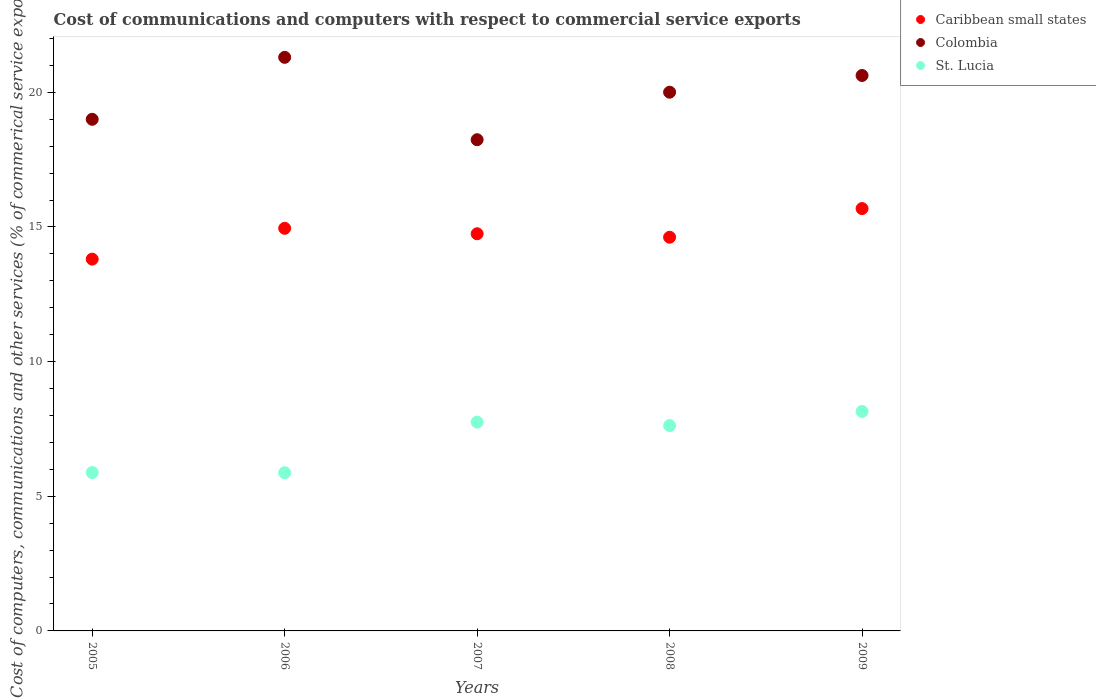How many different coloured dotlines are there?
Your answer should be compact. 3. Is the number of dotlines equal to the number of legend labels?
Provide a short and direct response. Yes. What is the cost of communications and computers in Caribbean small states in 2007?
Offer a very short reply. 14.75. Across all years, what is the maximum cost of communications and computers in St. Lucia?
Make the answer very short. 8.15. Across all years, what is the minimum cost of communications and computers in Caribbean small states?
Ensure brevity in your answer.  13.81. What is the total cost of communications and computers in Colombia in the graph?
Give a very brief answer. 99.17. What is the difference between the cost of communications and computers in Colombia in 2006 and that in 2009?
Give a very brief answer. 0.67. What is the difference between the cost of communications and computers in Colombia in 2006 and the cost of communications and computers in St. Lucia in 2007?
Your answer should be compact. 13.55. What is the average cost of communications and computers in St. Lucia per year?
Keep it short and to the point. 7.06. In the year 2009, what is the difference between the cost of communications and computers in St. Lucia and cost of communications and computers in Colombia?
Make the answer very short. -12.48. What is the ratio of the cost of communications and computers in Colombia in 2007 to that in 2008?
Provide a short and direct response. 0.91. Is the cost of communications and computers in St. Lucia in 2007 less than that in 2009?
Keep it short and to the point. Yes. What is the difference between the highest and the second highest cost of communications and computers in St. Lucia?
Keep it short and to the point. 0.4. What is the difference between the highest and the lowest cost of communications and computers in Caribbean small states?
Ensure brevity in your answer.  1.88. Does the cost of communications and computers in Colombia monotonically increase over the years?
Ensure brevity in your answer.  No. How many years are there in the graph?
Provide a succinct answer. 5. How are the legend labels stacked?
Keep it short and to the point. Vertical. What is the title of the graph?
Provide a succinct answer. Cost of communications and computers with respect to commercial service exports. What is the label or title of the X-axis?
Provide a short and direct response. Years. What is the label or title of the Y-axis?
Offer a very short reply. Cost of computers, communications and other services (% of commerical service exports). What is the Cost of computers, communications and other services (% of commerical service exports) in Caribbean small states in 2005?
Your response must be concise. 13.81. What is the Cost of computers, communications and other services (% of commerical service exports) in Colombia in 2005?
Your answer should be compact. 19. What is the Cost of computers, communications and other services (% of commerical service exports) of St. Lucia in 2005?
Your answer should be very brief. 5.88. What is the Cost of computers, communications and other services (% of commerical service exports) in Caribbean small states in 2006?
Offer a very short reply. 14.95. What is the Cost of computers, communications and other services (% of commerical service exports) of Colombia in 2006?
Your response must be concise. 21.3. What is the Cost of computers, communications and other services (% of commerical service exports) in St. Lucia in 2006?
Offer a terse response. 5.87. What is the Cost of computers, communications and other services (% of commerical service exports) in Caribbean small states in 2007?
Provide a short and direct response. 14.75. What is the Cost of computers, communications and other services (% of commerical service exports) of Colombia in 2007?
Offer a very short reply. 18.24. What is the Cost of computers, communications and other services (% of commerical service exports) of St. Lucia in 2007?
Offer a terse response. 7.75. What is the Cost of computers, communications and other services (% of commerical service exports) in Caribbean small states in 2008?
Give a very brief answer. 14.62. What is the Cost of computers, communications and other services (% of commerical service exports) of Colombia in 2008?
Ensure brevity in your answer.  20. What is the Cost of computers, communications and other services (% of commerical service exports) of St. Lucia in 2008?
Offer a terse response. 7.63. What is the Cost of computers, communications and other services (% of commerical service exports) in Caribbean small states in 2009?
Ensure brevity in your answer.  15.68. What is the Cost of computers, communications and other services (% of commerical service exports) of Colombia in 2009?
Ensure brevity in your answer.  20.63. What is the Cost of computers, communications and other services (% of commerical service exports) of St. Lucia in 2009?
Your answer should be very brief. 8.15. Across all years, what is the maximum Cost of computers, communications and other services (% of commerical service exports) in Caribbean small states?
Provide a succinct answer. 15.68. Across all years, what is the maximum Cost of computers, communications and other services (% of commerical service exports) in Colombia?
Make the answer very short. 21.3. Across all years, what is the maximum Cost of computers, communications and other services (% of commerical service exports) of St. Lucia?
Ensure brevity in your answer.  8.15. Across all years, what is the minimum Cost of computers, communications and other services (% of commerical service exports) of Caribbean small states?
Provide a succinct answer. 13.81. Across all years, what is the minimum Cost of computers, communications and other services (% of commerical service exports) of Colombia?
Your response must be concise. 18.24. Across all years, what is the minimum Cost of computers, communications and other services (% of commerical service exports) of St. Lucia?
Offer a very short reply. 5.87. What is the total Cost of computers, communications and other services (% of commerical service exports) in Caribbean small states in the graph?
Ensure brevity in your answer.  73.81. What is the total Cost of computers, communications and other services (% of commerical service exports) of Colombia in the graph?
Your answer should be very brief. 99.17. What is the total Cost of computers, communications and other services (% of commerical service exports) in St. Lucia in the graph?
Offer a very short reply. 35.28. What is the difference between the Cost of computers, communications and other services (% of commerical service exports) of Caribbean small states in 2005 and that in 2006?
Ensure brevity in your answer.  -1.14. What is the difference between the Cost of computers, communications and other services (% of commerical service exports) in Colombia in 2005 and that in 2006?
Offer a very short reply. -2.3. What is the difference between the Cost of computers, communications and other services (% of commerical service exports) in St. Lucia in 2005 and that in 2006?
Make the answer very short. 0.01. What is the difference between the Cost of computers, communications and other services (% of commerical service exports) in Caribbean small states in 2005 and that in 2007?
Provide a short and direct response. -0.94. What is the difference between the Cost of computers, communications and other services (% of commerical service exports) of Colombia in 2005 and that in 2007?
Provide a short and direct response. 0.76. What is the difference between the Cost of computers, communications and other services (% of commerical service exports) in St. Lucia in 2005 and that in 2007?
Offer a terse response. -1.87. What is the difference between the Cost of computers, communications and other services (% of commerical service exports) in Caribbean small states in 2005 and that in 2008?
Your answer should be compact. -0.81. What is the difference between the Cost of computers, communications and other services (% of commerical service exports) of Colombia in 2005 and that in 2008?
Provide a short and direct response. -1.01. What is the difference between the Cost of computers, communications and other services (% of commerical service exports) of St. Lucia in 2005 and that in 2008?
Your response must be concise. -1.74. What is the difference between the Cost of computers, communications and other services (% of commerical service exports) of Caribbean small states in 2005 and that in 2009?
Provide a succinct answer. -1.88. What is the difference between the Cost of computers, communications and other services (% of commerical service exports) in Colombia in 2005 and that in 2009?
Keep it short and to the point. -1.63. What is the difference between the Cost of computers, communications and other services (% of commerical service exports) of St. Lucia in 2005 and that in 2009?
Ensure brevity in your answer.  -2.27. What is the difference between the Cost of computers, communications and other services (% of commerical service exports) of Caribbean small states in 2006 and that in 2007?
Make the answer very short. 0.2. What is the difference between the Cost of computers, communications and other services (% of commerical service exports) in Colombia in 2006 and that in 2007?
Offer a very short reply. 3.06. What is the difference between the Cost of computers, communications and other services (% of commerical service exports) of St. Lucia in 2006 and that in 2007?
Offer a terse response. -1.88. What is the difference between the Cost of computers, communications and other services (% of commerical service exports) in Caribbean small states in 2006 and that in 2008?
Your answer should be very brief. 0.33. What is the difference between the Cost of computers, communications and other services (% of commerical service exports) of Colombia in 2006 and that in 2008?
Offer a very short reply. 1.29. What is the difference between the Cost of computers, communications and other services (% of commerical service exports) of St. Lucia in 2006 and that in 2008?
Provide a succinct answer. -1.75. What is the difference between the Cost of computers, communications and other services (% of commerical service exports) of Caribbean small states in 2006 and that in 2009?
Keep it short and to the point. -0.73. What is the difference between the Cost of computers, communications and other services (% of commerical service exports) in Colombia in 2006 and that in 2009?
Provide a succinct answer. 0.67. What is the difference between the Cost of computers, communications and other services (% of commerical service exports) in St. Lucia in 2006 and that in 2009?
Give a very brief answer. -2.27. What is the difference between the Cost of computers, communications and other services (% of commerical service exports) in Caribbean small states in 2007 and that in 2008?
Ensure brevity in your answer.  0.13. What is the difference between the Cost of computers, communications and other services (% of commerical service exports) of Colombia in 2007 and that in 2008?
Offer a very short reply. -1.76. What is the difference between the Cost of computers, communications and other services (% of commerical service exports) in St. Lucia in 2007 and that in 2008?
Provide a succinct answer. 0.13. What is the difference between the Cost of computers, communications and other services (% of commerical service exports) in Caribbean small states in 2007 and that in 2009?
Provide a short and direct response. -0.94. What is the difference between the Cost of computers, communications and other services (% of commerical service exports) in Colombia in 2007 and that in 2009?
Keep it short and to the point. -2.38. What is the difference between the Cost of computers, communications and other services (% of commerical service exports) in St. Lucia in 2007 and that in 2009?
Your response must be concise. -0.4. What is the difference between the Cost of computers, communications and other services (% of commerical service exports) in Caribbean small states in 2008 and that in 2009?
Offer a terse response. -1.06. What is the difference between the Cost of computers, communications and other services (% of commerical service exports) in Colombia in 2008 and that in 2009?
Keep it short and to the point. -0.62. What is the difference between the Cost of computers, communications and other services (% of commerical service exports) in St. Lucia in 2008 and that in 2009?
Your answer should be compact. -0.52. What is the difference between the Cost of computers, communications and other services (% of commerical service exports) in Caribbean small states in 2005 and the Cost of computers, communications and other services (% of commerical service exports) in Colombia in 2006?
Your answer should be very brief. -7.49. What is the difference between the Cost of computers, communications and other services (% of commerical service exports) of Caribbean small states in 2005 and the Cost of computers, communications and other services (% of commerical service exports) of St. Lucia in 2006?
Provide a succinct answer. 7.93. What is the difference between the Cost of computers, communications and other services (% of commerical service exports) of Colombia in 2005 and the Cost of computers, communications and other services (% of commerical service exports) of St. Lucia in 2006?
Your answer should be very brief. 13.12. What is the difference between the Cost of computers, communications and other services (% of commerical service exports) of Caribbean small states in 2005 and the Cost of computers, communications and other services (% of commerical service exports) of Colombia in 2007?
Keep it short and to the point. -4.43. What is the difference between the Cost of computers, communications and other services (% of commerical service exports) in Caribbean small states in 2005 and the Cost of computers, communications and other services (% of commerical service exports) in St. Lucia in 2007?
Keep it short and to the point. 6.05. What is the difference between the Cost of computers, communications and other services (% of commerical service exports) in Colombia in 2005 and the Cost of computers, communications and other services (% of commerical service exports) in St. Lucia in 2007?
Your answer should be compact. 11.25. What is the difference between the Cost of computers, communications and other services (% of commerical service exports) of Caribbean small states in 2005 and the Cost of computers, communications and other services (% of commerical service exports) of Colombia in 2008?
Keep it short and to the point. -6.2. What is the difference between the Cost of computers, communications and other services (% of commerical service exports) of Caribbean small states in 2005 and the Cost of computers, communications and other services (% of commerical service exports) of St. Lucia in 2008?
Your answer should be compact. 6.18. What is the difference between the Cost of computers, communications and other services (% of commerical service exports) in Colombia in 2005 and the Cost of computers, communications and other services (% of commerical service exports) in St. Lucia in 2008?
Your response must be concise. 11.37. What is the difference between the Cost of computers, communications and other services (% of commerical service exports) in Caribbean small states in 2005 and the Cost of computers, communications and other services (% of commerical service exports) in Colombia in 2009?
Give a very brief answer. -6.82. What is the difference between the Cost of computers, communications and other services (% of commerical service exports) in Caribbean small states in 2005 and the Cost of computers, communications and other services (% of commerical service exports) in St. Lucia in 2009?
Provide a short and direct response. 5.66. What is the difference between the Cost of computers, communications and other services (% of commerical service exports) in Colombia in 2005 and the Cost of computers, communications and other services (% of commerical service exports) in St. Lucia in 2009?
Ensure brevity in your answer.  10.85. What is the difference between the Cost of computers, communications and other services (% of commerical service exports) of Caribbean small states in 2006 and the Cost of computers, communications and other services (% of commerical service exports) of Colombia in 2007?
Offer a very short reply. -3.29. What is the difference between the Cost of computers, communications and other services (% of commerical service exports) in Caribbean small states in 2006 and the Cost of computers, communications and other services (% of commerical service exports) in St. Lucia in 2007?
Your answer should be compact. 7.2. What is the difference between the Cost of computers, communications and other services (% of commerical service exports) of Colombia in 2006 and the Cost of computers, communications and other services (% of commerical service exports) of St. Lucia in 2007?
Your response must be concise. 13.55. What is the difference between the Cost of computers, communications and other services (% of commerical service exports) of Caribbean small states in 2006 and the Cost of computers, communications and other services (% of commerical service exports) of Colombia in 2008?
Make the answer very short. -5.05. What is the difference between the Cost of computers, communications and other services (% of commerical service exports) in Caribbean small states in 2006 and the Cost of computers, communications and other services (% of commerical service exports) in St. Lucia in 2008?
Your response must be concise. 7.33. What is the difference between the Cost of computers, communications and other services (% of commerical service exports) in Colombia in 2006 and the Cost of computers, communications and other services (% of commerical service exports) in St. Lucia in 2008?
Offer a terse response. 13.67. What is the difference between the Cost of computers, communications and other services (% of commerical service exports) in Caribbean small states in 2006 and the Cost of computers, communications and other services (% of commerical service exports) in Colombia in 2009?
Offer a very short reply. -5.67. What is the difference between the Cost of computers, communications and other services (% of commerical service exports) in Caribbean small states in 2006 and the Cost of computers, communications and other services (% of commerical service exports) in St. Lucia in 2009?
Provide a succinct answer. 6.8. What is the difference between the Cost of computers, communications and other services (% of commerical service exports) in Colombia in 2006 and the Cost of computers, communications and other services (% of commerical service exports) in St. Lucia in 2009?
Provide a succinct answer. 13.15. What is the difference between the Cost of computers, communications and other services (% of commerical service exports) in Caribbean small states in 2007 and the Cost of computers, communications and other services (% of commerical service exports) in Colombia in 2008?
Offer a very short reply. -5.26. What is the difference between the Cost of computers, communications and other services (% of commerical service exports) of Caribbean small states in 2007 and the Cost of computers, communications and other services (% of commerical service exports) of St. Lucia in 2008?
Keep it short and to the point. 7.12. What is the difference between the Cost of computers, communications and other services (% of commerical service exports) in Colombia in 2007 and the Cost of computers, communications and other services (% of commerical service exports) in St. Lucia in 2008?
Ensure brevity in your answer.  10.62. What is the difference between the Cost of computers, communications and other services (% of commerical service exports) in Caribbean small states in 2007 and the Cost of computers, communications and other services (% of commerical service exports) in Colombia in 2009?
Your answer should be compact. -5.88. What is the difference between the Cost of computers, communications and other services (% of commerical service exports) of Caribbean small states in 2007 and the Cost of computers, communications and other services (% of commerical service exports) of St. Lucia in 2009?
Offer a terse response. 6.6. What is the difference between the Cost of computers, communications and other services (% of commerical service exports) in Colombia in 2007 and the Cost of computers, communications and other services (% of commerical service exports) in St. Lucia in 2009?
Your answer should be very brief. 10.09. What is the difference between the Cost of computers, communications and other services (% of commerical service exports) in Caribbean small states in 2008 and the Cost of computers, communications and other services (% of commerical service exports) in Colombia in 2009?
Your response must be concise. -6.01. What is the difference between the Cost of computers, communications and other services (% of commerical service exports) in Caribbean small states in 2008 and the Cost of computers, communications and other services (% of commerical service exports) in St. Lucia in 2009?
Make the answer very short. 6.47. What is the difference between the Cost of computers, communications and other services (% of commerical service exports) in Colombia in 2008 and the Cost of computers, communications and other services (% of commerical service exports) in St. Lucia in 2009?
Your response must be concise. 11.86. What is the average Cost of computers, communications and other services (% of commerical service exports) of Caribbean small states per year?
Make the answer very short. 14.76. What is the average Cost of computers, communications and other services (% of commerical service exports) in Colombia per year?
Your answer should be very brief. 19.83. What is the average Cost of computers, communications and other services (% of commerical service exports) in St. Lucia per year?
Keep it short and to the point. 7.06. In the year 2005, what is the difference between the Cost of computers, communications and other services (% of commerical service exports) of Caribbean small states and Cost of computers, communications and other services (% of commerical service exports) of Colombia?
Provide a short and direct response. -5.19. In the year 2005, what is the difference between the Cost of computers, communications and other services (% of commerical service exports) of Caribbean small states and Cost of computers, communications and other services (% of commerical service exports) of St. Lucia?
Ensure brevity in your answer.  7.93. In the year 2005, what is the difference between the Cost of computers, communications and other services (% of commerical service exports) of Colombia and Cost of computers, communications and other services (% of commerical service exports) of St. Lucia?
Keep it short and to the point. 13.12. In the year 2006, what is the difference between the Cost of computers, communications and other services (% of commerical service exports) of Caribbean small states and Cost of computers, communications and other services (% of commerical service exports) of Colombia?
Offer a terse response. -6.35. In the year 2006, what is the difference between the Cost of computers, communications and other services (% of commerical service exports) of Caribbean small states and Cost of computers, communications and other services (% of commerical service exports) of St. Lucia?
Make the answer very short. 9.08. In the year 2006, what is the difference between the Cost of computers, communications and other services (% of commerical service exports) of Colombia and Cost of computers, communications and other services (% of commerical service exports) of St. Lucia?
Ensure brevity in your answer.  15.42. In the year 2007, what is the difference between the Cost of computers, communications and other services (% of commerical service exports) in Caribbean small states and Cost of computers, communications and other services (% of commerical service exports) in Colombia?
Your answer should be very brief. -3.49. In the year 2007, what is the difference between the Cost of computers, communications and other services (% of commerical service exports) in Caribbean small states and Cost of computers, communications and other services (% of commerical service exports) in St. Lucia?
Provide a short and direct response. 6.99. In the year 2007, what is the difference between the Cost of computers, communications and other services (% of commerical service exports) in Colombia and Cost of computers, communications and other services (% of commerical service exports) in St. Lucia?
Your answer should be compact. 10.49. In the year 2008, what is the difference between the Cost of computers, communications and other services (% of commerical service exports) in Caribbean small states and Cost of computers, communications and other services (% of commerical service exports) in Colombia?
Your response must be concise. -5.38. In the year 2008, what is the difference between the Cost of computers, communications and other services (% of commerical service exports) in Caribbean small states and Cost of computers, communications and other services (% of commerical service exports) in St. Lucia?
Your answer should be compact. 6.99. In the year 2008, what is the difference between the Cost of computers, communications and other services (% of commerical service exports) in Colombia and Cost of computers, communications and other services (% of commerical service exports) in St. Lucia?
Make the answer very short. 12.38. In the year 2009, what is the difference between the Cost of computers, communications and other services (% of commerical service exports) in Caribbean small states and Cost of computers, communications and other services (% of commerical service exports) in Colombia?
Ensure brevity in your answer.  -4.94. In the year 2009, what is the difference between the Cost of computers, communications and other services (% of commerical service exports) in Caribbean small states and Cost of computers, communications and other services (% of commerical service exports) in St. Lucia?
Offer a very short reply. 7.53. In the year 2009, what is the difference between the Cost of computers, communications and other services (% of commerical service exports) in Colombia and Cost of computers, communications and other services (% of commerical service exports) in St. Lucia?
Your answer should be compact. 12.48. What is the ratio of the Cost of computers, communications and other services (% of commerical service exports) of Caribbean small states in 2005 to that in 2006?
Ensure brevity in your answer.  0.92. What is the ratio of the Cost of computers, communications and other services (% of commerical service exports) of Colombia in 2005 to that in 2006?
Ensure brevity in your answer.  0.89. What is the ratio of the Cost of computers, communications and other services (% of commerical service exports) in St. Lucia in 2005 to that in 2006?
Offer a terse response. 1. What is the ratio of the Cost of computers, communications and other services (% of commerical service exports) of Caribbean small states in 2005 to that in 2007?
Keep it short and to the point. 0.94. What is the ratio of the Cost of computers, communications and other services (% of commerical service exports) of Colombia in 2005 to that in 2007?
Your response must be concise. 1.04. What is the ratio of the Cost of computers, communications and other services (% of commerical service exports) of St. Lucia in 2005 to that in 2007?
Ensure brevity in your answer.  0.76. What is the ratio of the Cost of computers, communications and other services (% of commerical service exports) in Caribbean small states in 2005 to that in 2008?
Your answer should be very brief. 0.94. What is the ratio of the Cost of computers, communications and other services (% of commerical service exports) of Colombia in 2005 to that in 2008?
Give a very brief answer. 0.95. What is the ratio of the Cost of computers, communications and other services (% of commerical service exports) in St. Lucia in 2005 to that in 2008?
Your answer should be very brief. 0.77. What is the ratio of the Cost of computers, communications and other services (% of commerical service exports) in Caribbean small states in 2005 to that in 2009?
Your answer should be compact. 0.88. What is the ratio of the Cost of computers, communications and other services (% of commerical service exports) of Colombia in 2005 to that in 2009?
Provide a short and direct response. 0.92. What is the ratio of the Cost of computers, communications and other services (% of commerical service exports) in St. Lucia in 2005 to that in 2009?
Provide a succinct answer. 0.72. What is the ratio of the Cost of computers, communications and other services (% of commerical service exports) of Caribbean small states in 2006 to that in 2007?
Your answer should be very brief. 1.01. What is the ratio of the Cost of computers, communications and other services (% of commerical service exports) in Colombia in 2006 to that in 2007?
Ensure brevity in your answer.  1.17. What is the ratio of the Cost of computers, communications and other services (% of commerical service exports) of St. Lucia in 2006 to that in 2007?
Your answer should be compact. 0.76. What is the ratio of the Cost of computers, communications and other services (% of commerical service exports) in Caribbean small states in 2006 to that in 2008?
Provide a succinct answer. 1.02. What is the ratio of the Cost of computers, communications and other services (% of commerical service exports) of Colombia in 2006 to that in 2008?
Provide a short and direct response. 1.06. What is the ratio of the Cost of computers, communications and other services (% of commerical service exports) of St. Lucia in 2006 to that in 2008?
Provide a short and direct response. 0.77. What is the ratio of the Cost of computers, communications and other services (% of commerical service exports) in Caribbean small states in 2006 to that in 2009?
Keep it short and to the point. 0.95. What is the ratio of the Cost of computers, communications and other services (% of commerical service exports) in Colombia in 2006 to that in 2009?
Ensure brevity in your answer.  1.03. What is the ratio of the Cost of computers, communications and other services (% of commerical service exports) of St. Lucia in 2006 to that in 2009?
Offer a very short reply. 0.72. What is the ratio of the Cost of computers, communications and other services (% of commerical service exports) of Caribbean small states in 2007 to that in 2008?
Provide a succinct answer. 1.01. What is the ratio of the Cost of computers, communications and other services (% of commerical service exports) of Colombia in 2007 to that in 2008?
Give a very brief answer. 0.91. What is the ratio of the Cost of computers, communications and other services (% of commerical service exports) of St. Lucia in 2007 to that in 2008?
Your response must be concise. 1.02. What is the ratio of the Cost of computers, communications and other services (% of commerical service exports) in Caribbean small states in 2007 to that in 2009?
Your answer should be compact. 0.94. What is the ratio of the Cost of computers, communications and other services (% of commerical service exports) in Colombia in 2007 to that in 2009?
Make the answer very short. 0.88. What is the ratio of the Cost of computers, communications and other services (% of commerical service exports) of St. Lucia in 2007 to that in 2009?
Make the answer very short. 0.95. What is the ratio of the Cost of computers, communications and other services (% of commerical service exports) of Caribbean small states in 2008 to that in 2009?
Your answer should be compact. 0.93. What is the ratio of the Cost of computers, communications and other services (% of commerical service exports) in Colombia in 2008 to that in 2009?
Make the answer very short. 0.97. What is the ratio of the Cost of computers, communications and other services (% of commerical service exports) of St. Lucia in 2008 to that in 2009?
Your response must be concise. 0.94. What is the difference between the highest and the second highest Cost of computers, communications and other services (% of commerical service exports) of Caribbean small states?
Provide a short and direct response. 0.73. What is the difference between the highest and the second highest Cost of computers, communications and other services (% of commerical service exports) of Colombia?
Provide a succinct answer. 0.67. What is the difference between the highest and the second highest Cost of computers, communications and other services (% of commerical service exports) of St. Lucia?
Provide a short and direct response. 0.4. What is the difference between the highest and the lowest Cost of computers, communications and other services (% of commerical service exports) in Caribbean small states?
Keep it short and to the point. 1.88. What is the difference between the highest and the lowest Cost of computers, communications and other services (% of commerical service exports) of Colombia?
Your answer should be very brief. 3.06. What is the difference between the highest and the lowest Cost of computers, communications and other services (% of commerical service exports) in St. Lucia?
Keep it short and to the point. 2.27. 